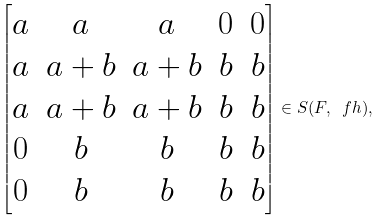Convert formula to latex. <formula><loc_0><loc_0><loc_500><loc_500>\begin{bmatrix} a & a & a & 0 & 0 \\ a & a + b & a + b & b & b \\ a & a + b & a + b & b & b \\ 0 & b & b & b & b \\ 0 & b & b & b & b \end{bmatrix} \in S ( F , \ f h ) ,</formula> 